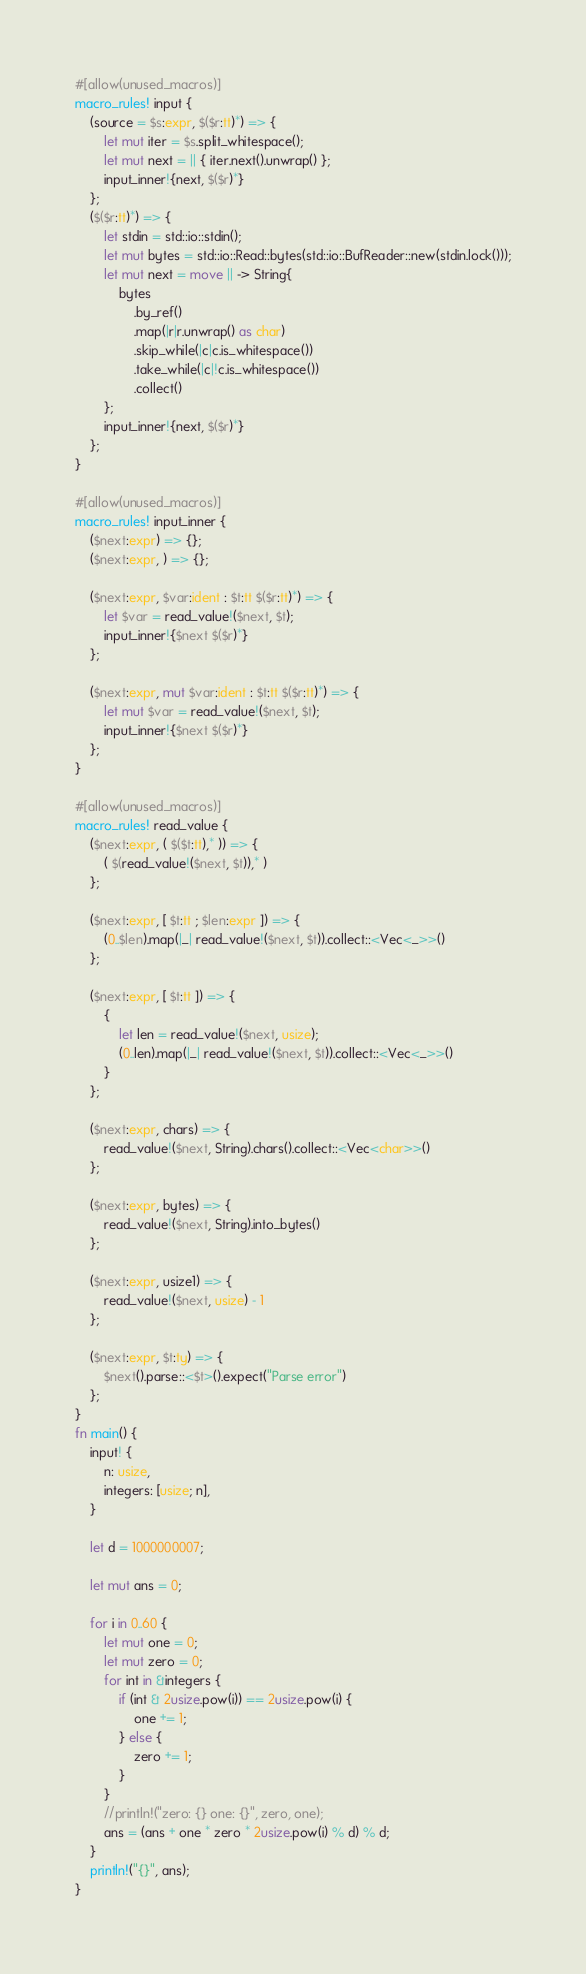<code> <loc_0><loc_0><loc_500><loc_500><_Rust_>#[allow(unused_macros)]
macro_rules! input {
    (source = $s:expr, $($r:tt)*) => {
        let mut iter = $s.split_whitespace();
        let mut next = || { iter.next().unwrap() };
        input_inner!{next, $($r)*}
    };
    ($($r:tt)*) => {
        let stdin = std::io::stdin();
        let mut bytes = std::io::Read::bytes(std::io::BufReader::new(stdin.lock()));
        let mut next = move || -> String{
            bytes
                .by_ref()
                .map(|r|r.unwrap() as char)
                .skip_while(|c|c.is_whitespace())
                .take_while(|c|!c.is_whitespace())
                .collect()
        };
        input_inner!{next, $($r)*}
    };
}
 
#[allow(unused_macros)]
macro_rules! input_inner {
    ($next:expr) => {};
    ($next:expr, ) => {};
 
    ($next:expr, $var:ident : $t:tt $($r:tt)*) => {
        let $var = read_value!($next, $t);
        input_inner!{$next $($r)*}
    };
 
    ($next:expr, mut $var:ident : $t:tt $($r:tt)*) => {
        let mut $var = read_value!($next, $t);
        input_inner!{$next $($r)*}
    };
}
 
#[allow(unused_macros)]
macro_rules! read_value {
    ($next:expr, ( $($t:tt),* )) => {
        ( $(read_value!($next, $t)),* )
    };
 
    ($next:expr, [ $t:tt ; $len:expr ]) => {
        (0..$len).map(|_| read_value!($next, $t)).collect::<Vec<_>>()
    };
 
    ($next:expr, [ $t:tt ]) => {
        {
            let len = read_value!($next, usize);
            (0..len).map(|_| read_value!($next, $t)).collect::<Vec<_>>()
        }
    };
 
    ($next:expr, chars) => {
        read_value!($next, String).chars().collect::<Vec<char>>()
    };
 
    ($next:expr, bytes) => {
        read_value!($next, String).into_bytes()
    };
 
    ($next:expr, usize1) => {
        read_value!($next, usize) - 1
    };
 
    ($next:expr, $t:ty) => {
        $next().parse::<$t>().expect("Parse error")
    };
}
fn main() {
    input! {
        n: usize,
        integers: [usize; n],
    }

    let d = 1000000007;

    let mut ans = 0;

    for i in 0..60 {
        let mut one = 0;
        let mut zero = 0;
        for int in &integers {
            if (int & 2usize.pow(i)) == 2usize.pow(i) {
                one += 1;
            } else {
                zero += 1;
            }
        }
        //println!("zero: {} one: {}", zero, one);
        ans = (ans + one * zero * 2usize.pow(i) % d) % d;
    }
    println!("{}", ans);
}
</code> 